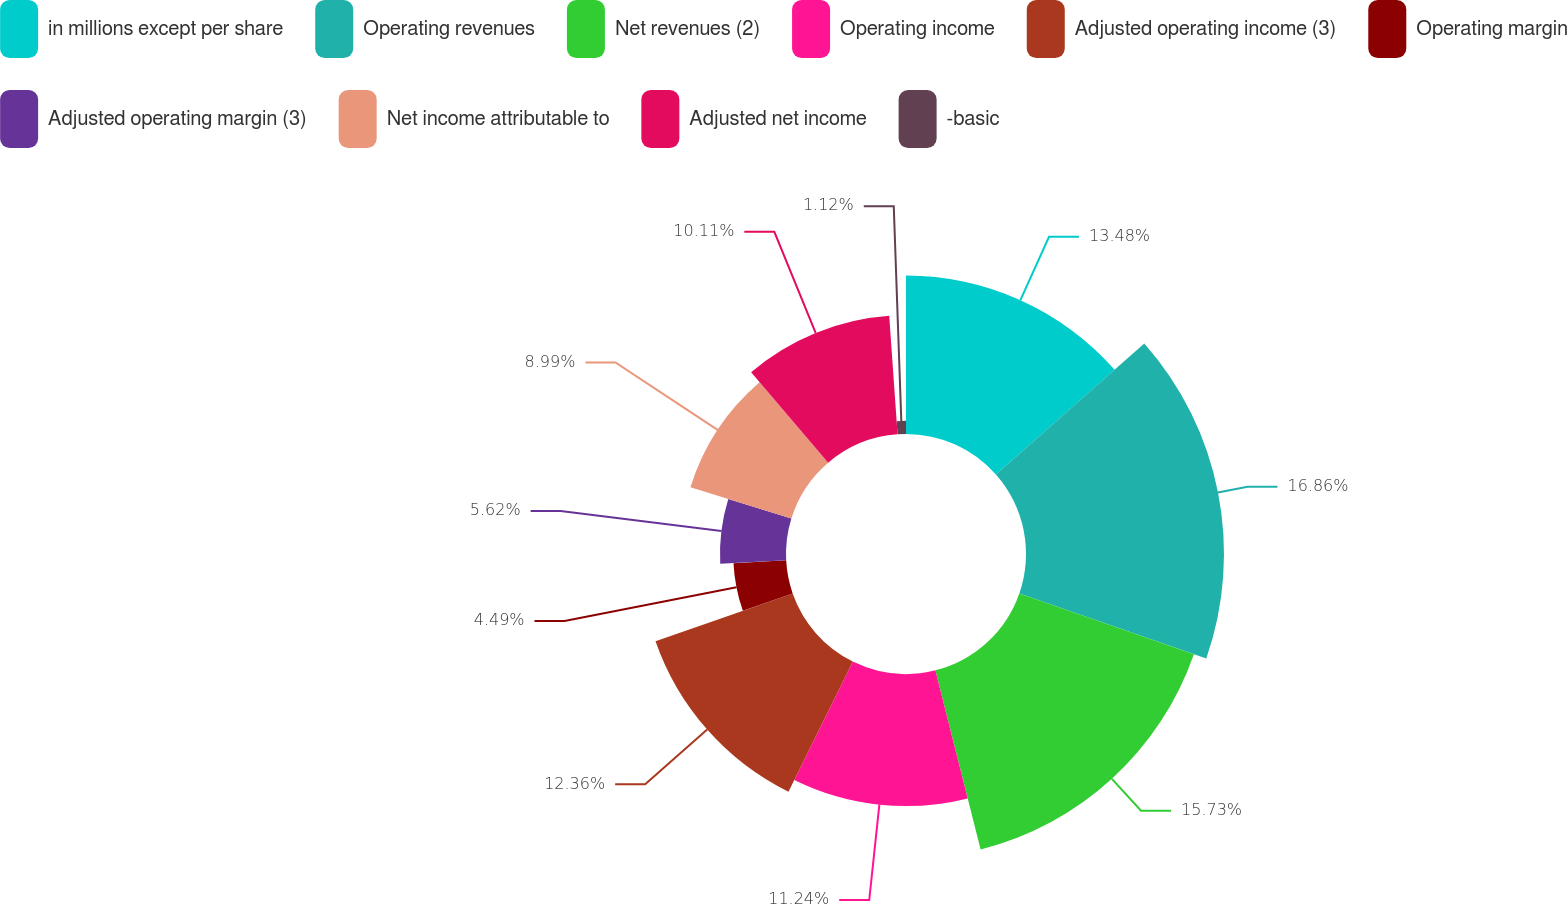Convert chart to OTSL. <chart><loc_0><loc_0><loc_500><loc_500><pie_chart><fcel>in millions except per share<fcel>Operating revenues<fcel>Net revenues (2)<fcel>Operating income<fcel>Adjusted operating income (3)<fcel>Operating margin<fcel>Adjusted operating margin (3)<fcel>Net income attributable to<fcel>Adjusted net income<fcel>-basic<nl><fcel>13.48%<fcel>16.85%<fcel>15.73%<fcel>11.24%<fcel>12.36%<fcel>4.49%<fcel>5.62%<fcel>8.99%<fcel>10.11%<fcel>1.12%<nl></chart> 